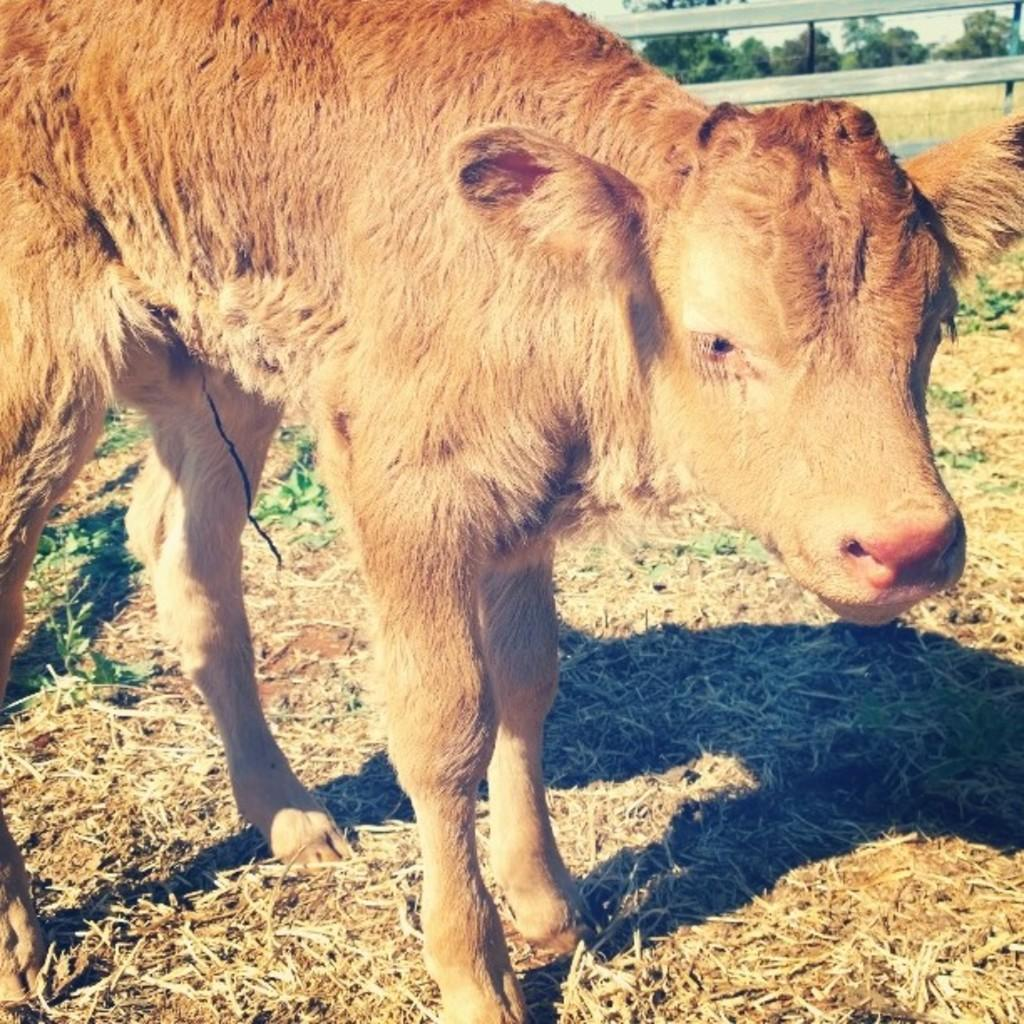What animal is present in the image? There is a cow in the image. What is the ground covered with in the image? The ground is covered with dry grass. How many ladybugs can be seen playing on the playground in the image? There is no playground or ladybugs present in the image; it features a cow and dry grass. 